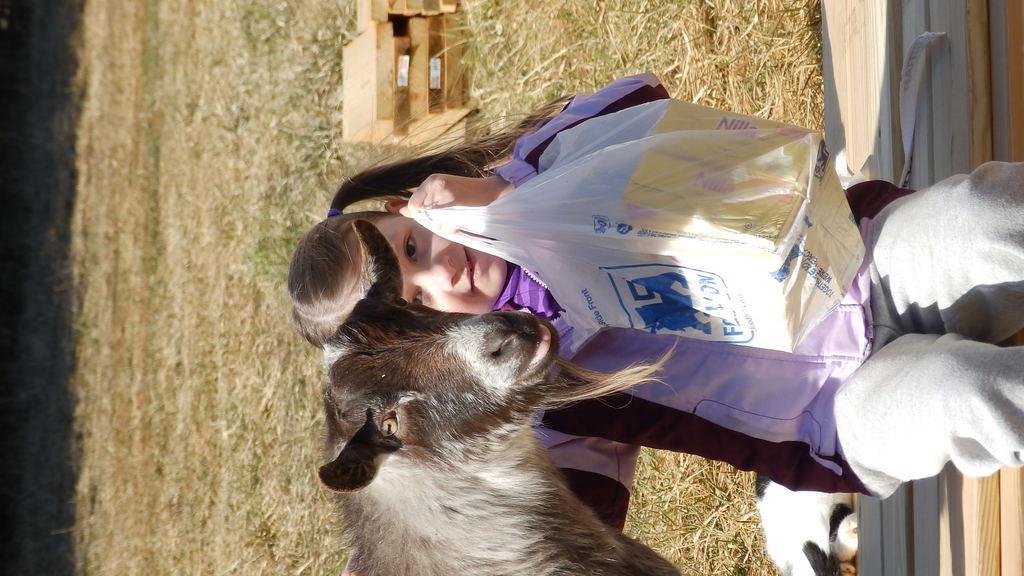Please provide a concise description of this image. There is a girl sitting on bench and a cover with boxes and we can see an animal. In the background we can see grass and boxes. 